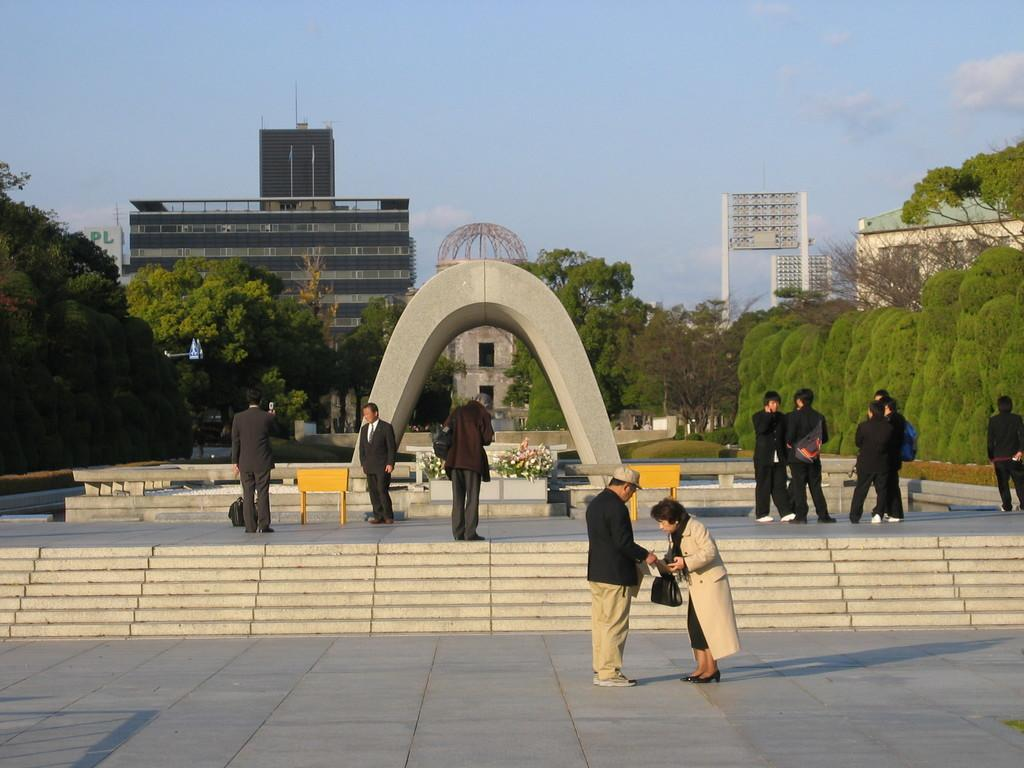Who or what is present in the image? There are people in the image. What architectural feature can be seen in the image? There are stairs in the image. What type of natural element is visible in the image? There are trees in the image. What type of man-made structures are present in the image? There are buildings in the image. What is visible at the top of the image? The sky is visible at the top of the image. What door is being used by the people in the image? There is no door present in the image; it only shows people, stairs, trees, buildings, and the sky. What is the desire of the trees in the image? Trees do not have desires, as they are inanimate objects. 